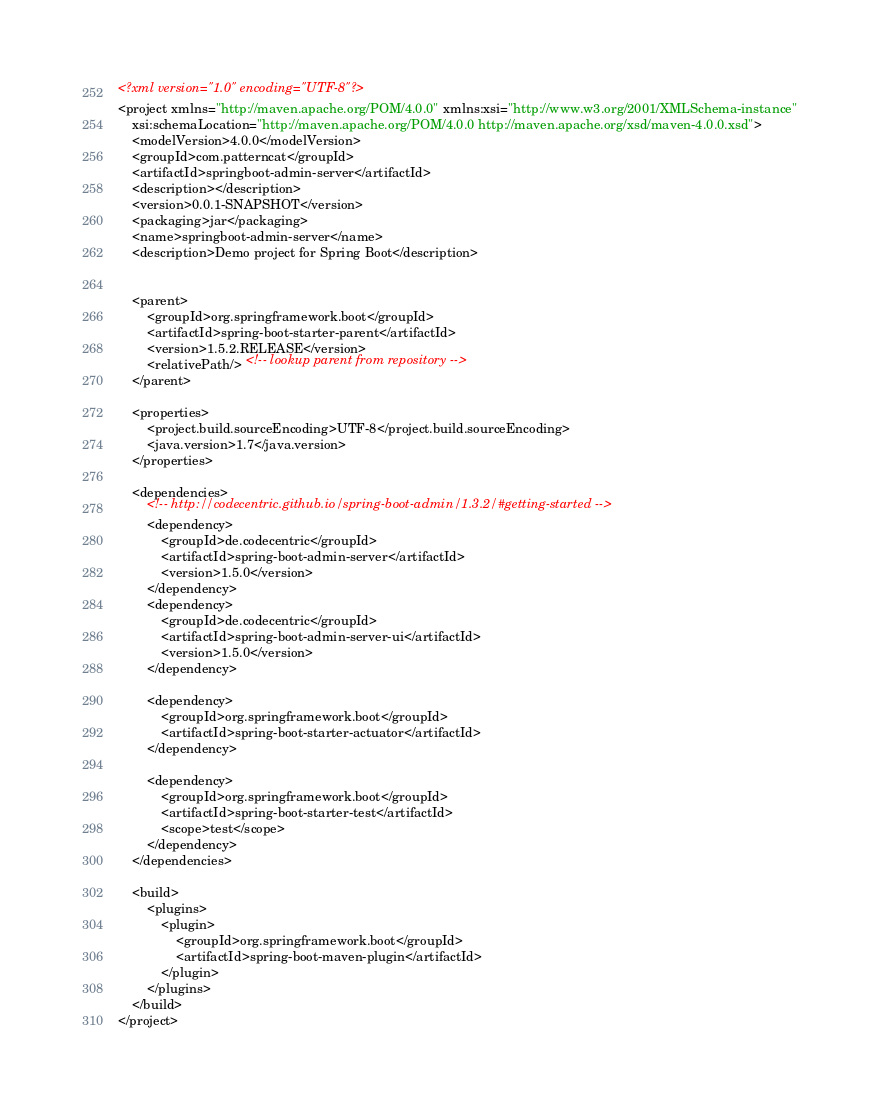Convert code to text. <code><loc_0><loc_0><loc_500><loc_500><_XML_><?xml version="1.0" encoding="UTF-8"?>
<project xmlns="http://maven.apache.org/POM/4.0.0" xmlns:xsi="http://www.w3.org/2001/XMLSchema-instance"
	xsi:schemaLocation="http://maven.apache.org/POM/4.0.0 http://maven.apache.org/xsd/maven-4.0.0.xsd">
	<modelVersion>4.0.0</modelVersion>
	<groupId>com.patterncat</groupId>
	<artifactId>springboot-admin-server</artifactId>
	<description></description>
	<version>0.0.1-SNAPSHOT</version>
	<packaging>jar</packaging>
	<name>springboot-admin-server</name>
	<description>Demo project for Spring Boot</description>


	<parent>
		<groupId>org.springframework.boot</groupId>
		<artifactId>spring-boot-starter-parent</artifactId>
		<version>1.5.2.RELEASE</version>
		<relativePath/> <!-- lookup parent from repository -->
	</parent>

	<properties>
		<project.build.sourceEncoding>UTF-8</project.build.sourceEncoding>
		<java.version>1.7</java.version>
	</properties>

	<dependencies>
		<!-- http://codecentric.github.io/spring-boot-admin/1.3.2/#getting-started -->
		<dependency>
			<groupId>de.codecentric</groupId>
			<artifactId>spring-boot-admin-server</artifactId>
			<version>1.5.0</version>
		</dependency>
		<dependency>
			<groupId>de.codecentric</groupId>
			<artifactId>spring-boot-admin-server-ui</artifactId>
			<version>1.5.0</version>
		</dependency>

		<dependency>
			<groupId>org.springframework.boot</groupId>
			<artifactId>spring-boot-starter-actuator</artifactId>
		</dependency>
		
		<dependency>
			<groupId>org.springframework.boot</groupId>
			<artifactId>spring-boot-starter-test</artifactId>
			<scope>test</scope>
		</dependency>
	</dependencies>
	
	<build>
		<plugins>
			<plugin>
				<groupId>org.springframework.boot</groupId>
				<artifactId>spring-boot-maven-plugin</artifactId>
			</plugin>
		</plugins>
	</build>
</project>
</code> 